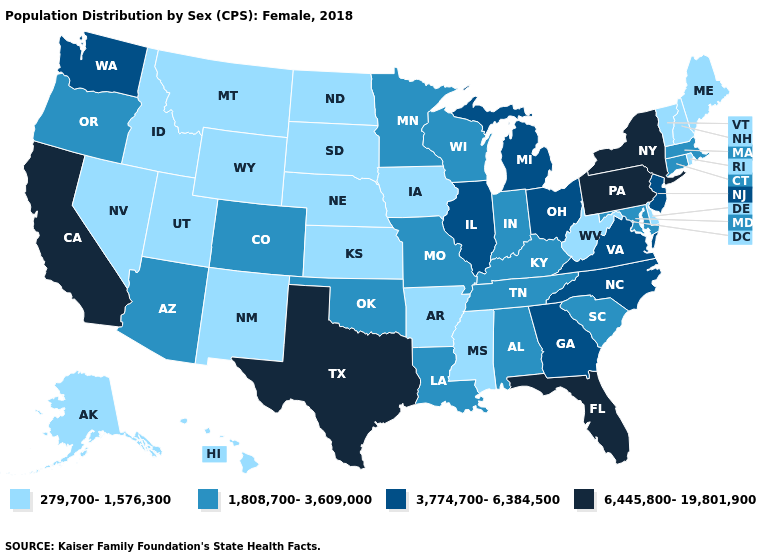Does California have the highest value in the USA?
Answer briefly. Yes. Name the states that have a value in the range 3,774,700-6,384,500?
Concise answer only. Georgia, Illinois, Michigan, New Jersey, North Carolina, Ohio, Virginia, Washington. Among the states that border Iowa , which have the highest value?
Quick response, please. Illinois. What is the value of Mississippi?
Keep it brief. 279,700-1,576,300. What is the value of Connecticut?
Short answer required. 1,808,700-3,609,000. What is the lowest value in the USA?
Keep it brief. 279,700-1,576,300. Does Wisconsin have the lowest value in the MidWest?
Concise answer only. No. Does the first symbol in the legend represent the smallest category?
Concise answer only. Yes. What is the value of Arkansas?
Keep it brief. 279,700-1,576,300. Which states have the lowest value in the USA?
Give a very brief answer. Alaska, Arkansas, Delaware, Hawaii, Idaho, Iowa, Kansas, Maine, Mississippi, Montana, Nebraska, Nevada, New Hampshire, New Mexico, North Dakota, Rhode Island, South Dakota, Utah, Vermont, West Virginia, Wyoming. Name the states that have a value in the range 3,774,700-6,384,500?
Quick response, please. Georgia, Illinois, Michigan, New Jersey, North Carolina, Ohio, Virginia, Washington. Does Vermont have the highest value in the Northeast?
Keep it brief. No. Which states have the highest value in the USA?
Concise answer only. California, Florida, New York, Pennsylvania, Texas. What is the value of Virginia?
Quick response, please. 3,774,700-6,384,500. What is the lowest value in states that border North Dakota?
Give a very brief answer. 279,700-1,576,300. 